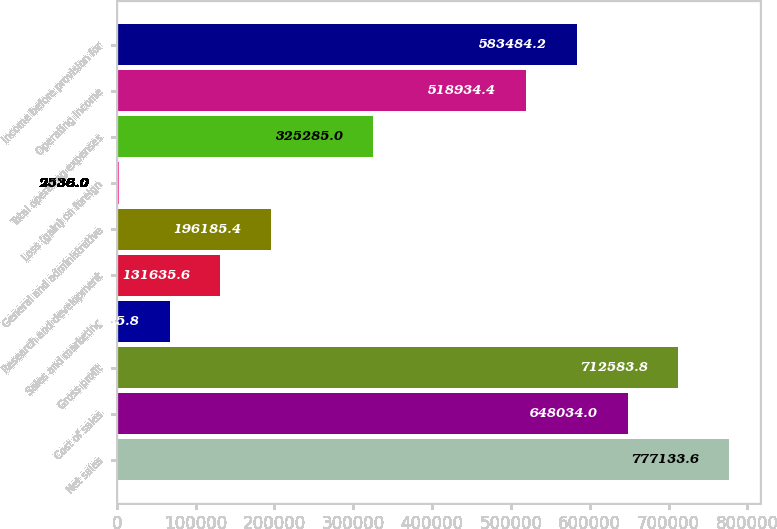<chart> <loc_0><loc_0><loc_500><loc_500><bar_chart><fcel>Net sales<fcel>Cost of sales<fcel>Gross profit<fcel>Sales and marketing<fcel>Research and development<fcel>General and administrative<fcel>Loss (gain) on foreign<fcel>Total operating expenses<fcel>Operating income<fcel>Income before provision for<nl><fcel>777134<fcel>648034<fcel>712584<fcel>67085.8<fcel>131636<fcel>196185<fcel>2536<fcel>325285<fcel>518934<fcel>583484<nl></chart> 